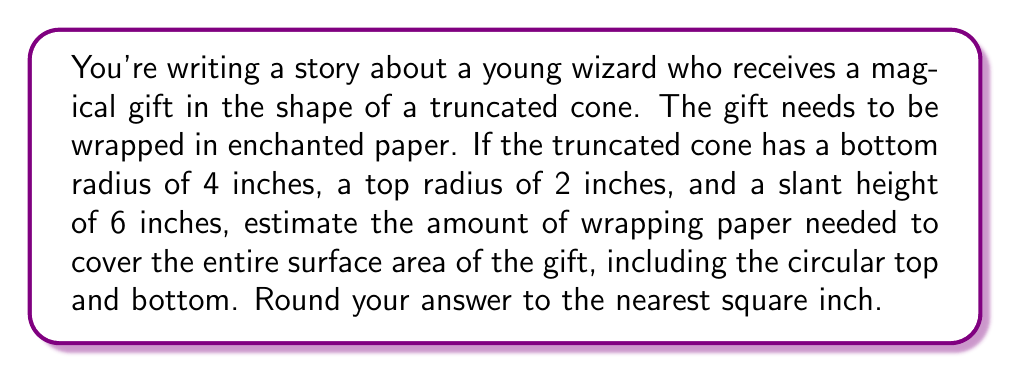Solve this math problem. To solve this problem, we need to calculate the surface area of a truncated cone. Let's break it down step-by-step:

1. Calculate the lateral surface area (the curved part):
   The formula for the lateral surface area of a truncated cone is:
   $$A_L = \pi(r_1 + r_2)s$$
   where $r_1$ is the bottom radius, $r_2$ is the top radius, and $s$ is the slant height.
   
   $$A_L = \pi(4 + 2) \cdot 6 = 6\pi \cdot 6 = 36\pi$$

2. Calculate the area of the bottom circle:
   $$A_B = \pi r_1^2 = \pi \cdot 4^2 = 16\pi$$

3. Calculate the area of the top circle:
   $$A_T = \pi r_2^2 = \pi \cdot 2^2 = 4\pi$$

4. Sum up all the areas:
   $$A_{total} = A_L + A_B + A_T = 36\pi + 16\pi + 4\pi = 56\pi$$

5. Convert to square inches and round to the nearest integer:
   $$56\pi \approx 175.92 \approx 176\text{ sq inches}$$

Therefore, approximately 176 square inches of enchanted wrapping paper are needed to cover the magical gift.
Answer: 176 sq inches 